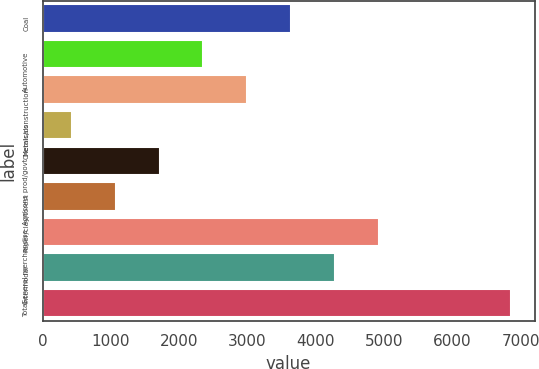Convert chart. <chart><loc_0><loc_0><loc_500><loc_500><bar_chart><fcel>Coal<fcel>Automotive<fcel>Metals/construction<fcel>Chemicals<fcel>Agr/cons prod/govt<fcel>Paper/clay/forest<fcel>General merchandise<fcel>Intermodal<fcel>Total<nl><fcel>3643.45<fcel>2356.35<fcel>2999.9<fcel>425.7<fcel>1712.8<fcel>1069.25<fcel>4930.55<fcel>4287<fcel>6861.2<nl></chart> 